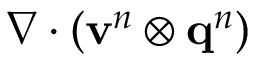<formula> <loc_0><loc_0><loc_500><loc_500>\nabla \cdot \left ( v ^ { n } \otimes q ^ { n } \right )</formula> 